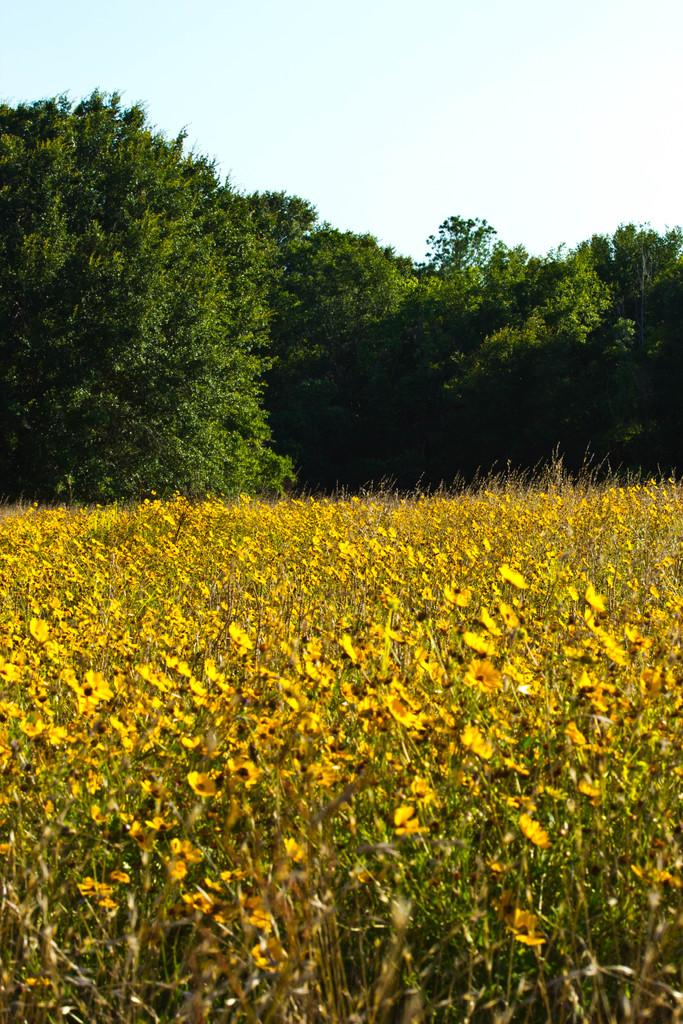What types of plants are in the foreground of the image? There are plants with flowers in the foreground of the image. What can be seen in the background of the image? There are trees in the background of the image. What is visible at the top of the image? The sky is visible at the top of the image. How many servants are present in the image? There are no servants present in the image. What type of loss is depicted in the image? There is no loss depicted in the image; it features plants, trees, and the sky. 